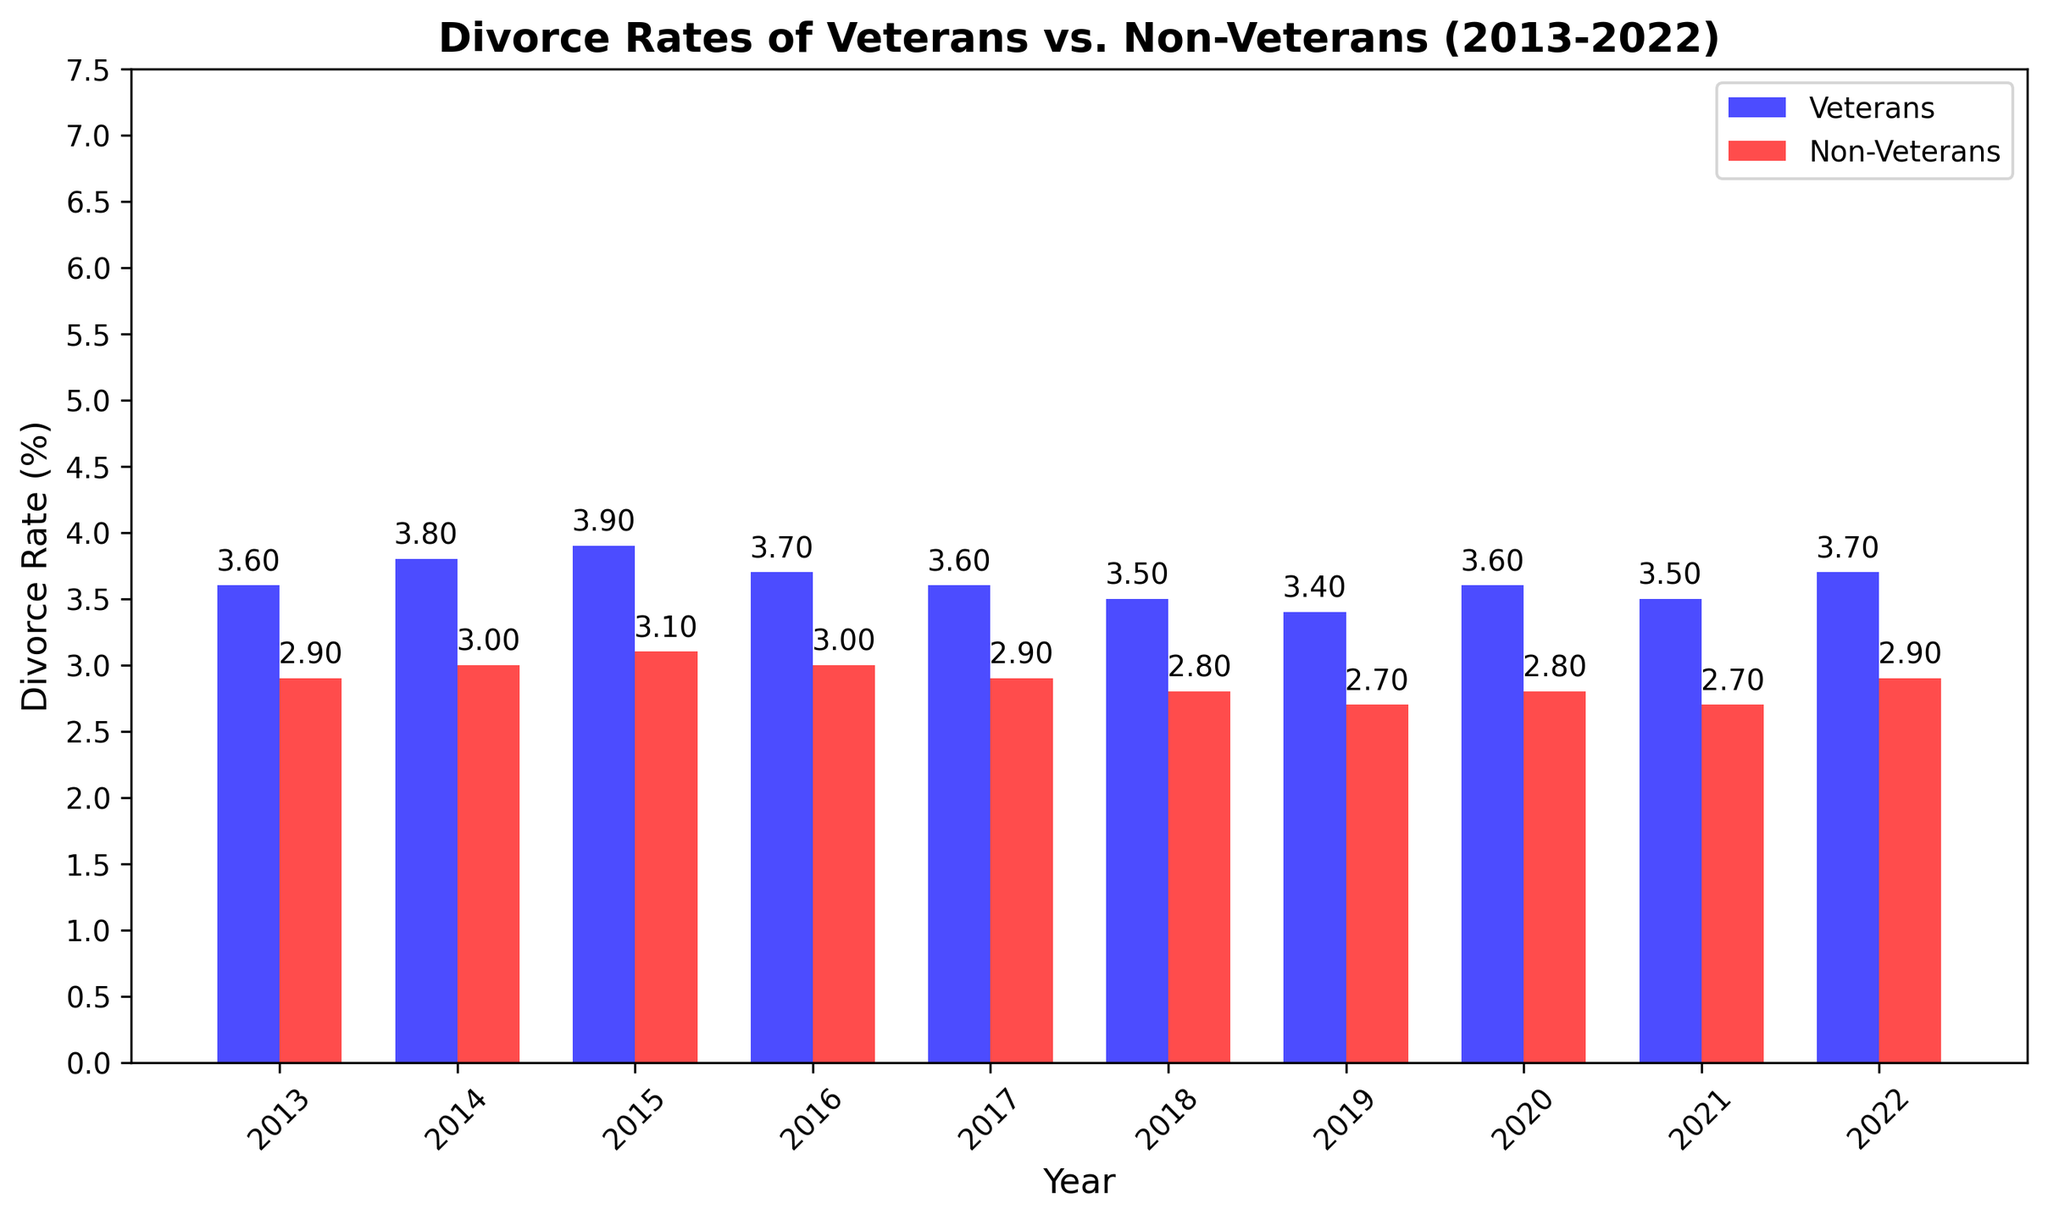Which year had the highest divorce rate for veterans? Looking at the height of the blue bars, the tallest bar for veterans is in 2015 with a divorce rate of 3.9%.
Answer: 2015 How does the divorce rate for non-veterans in 2022 compare to that for veterans in the same year? The red bar for non-veterans in 2022 has a height of 2.9%, while the blue bar for veterans has a height of 3.7%. The divorce rate for non-veterans is lower than that for veterans in 2022.
Answer: Lower Which group had a lower divorce rate on average over the decade? We need to calculate the average divorce rate for both veterans and non-veterans. Averaging the divorce rates for veterans is (3.6+3.8+3.9+3.7+3.6+3.5+3.4+3.6+3.5+3.7)/10 = 3.63. For non-veterans, it is (2.9+3.0+3.1+3.0+2.9+2.8+2.7+2.8+2.7+2.9)/10 = 2.88. The non-veterans have a lower average divorce rate.
Answer: Non-veterans What was the difference in divorce rate between veterans and non-veterans in 2019? The divorce rate for veterans in 2019 was 3.4%, and for non-veterans, it was 2.7%. Subtract the non-veterans' rate from the veterans' rate: 3.4 - 2.7 = 0.7.
Answer: 0.7 Did the divorce rate of veterans decrease or increase from 2013 to 2022? Comparing the blue bars for veterans in 2013 (3.6%) and in 2022 (3.7%), the divorce rate increased.
Answer: Increased What was the trend in divorce rates for non-veterans from 2016 to 2019? Observing the heights of the red bars for non-veterans: 2016 (3.0%), 2017 (2.9%), 2018 (2.8%), and 2019 (2.7%), there is a decreasing trend.
Answer: Decreasing In which years were the divorce rates for veterans and non-veterans equal? By comparing the heights of the blue and red bars for each year, we see that the divorce rates for both groups were never equal in any year.
Answer: Never By how much did the divorce rate for veterans change from 2014 to 2015? The divorce rate for veterans in 2014 was 3.8%, and in 2015 it was 3.9%. The difference is 3.9 - 3.8 = 0.1.
Answer: 0.1 Which year had the smallest difference in divorce rates between veterans and non-veterans? Reviewing the differences:
2013: 3.6 - 2.9 = 0.7
2014: 3.8 - 3.0 = 0.8
2015: 3.9 - 3.1 = 0.8
2016: 3.7 - 3.0 = 0.7
2017: 3.6 - 2.9 = 0.7
2018: 3.5 - 2.8 = 0.7
2019: 3.4 - 2.7 = 0.7
2020: 3.6 - 2.8 = 0.8
2021: 3.5 - 2.7 = 0.8
2022: 3.7 - 2.9 = 0.8
There are several years with the smallest difference of 0.7 (2013, 2016, 2017, 2018, 2019).
Answer: 2013, 2016, 2017, 2018, 2019 How many years showed a higher divorce rate for veterans compared to non-veterans? Inspecting the figure, every year from 2013 to 2022 shows veterans having higher divorce rates than non-veterans. Therefore, there are 10 years.
Answer: 10 